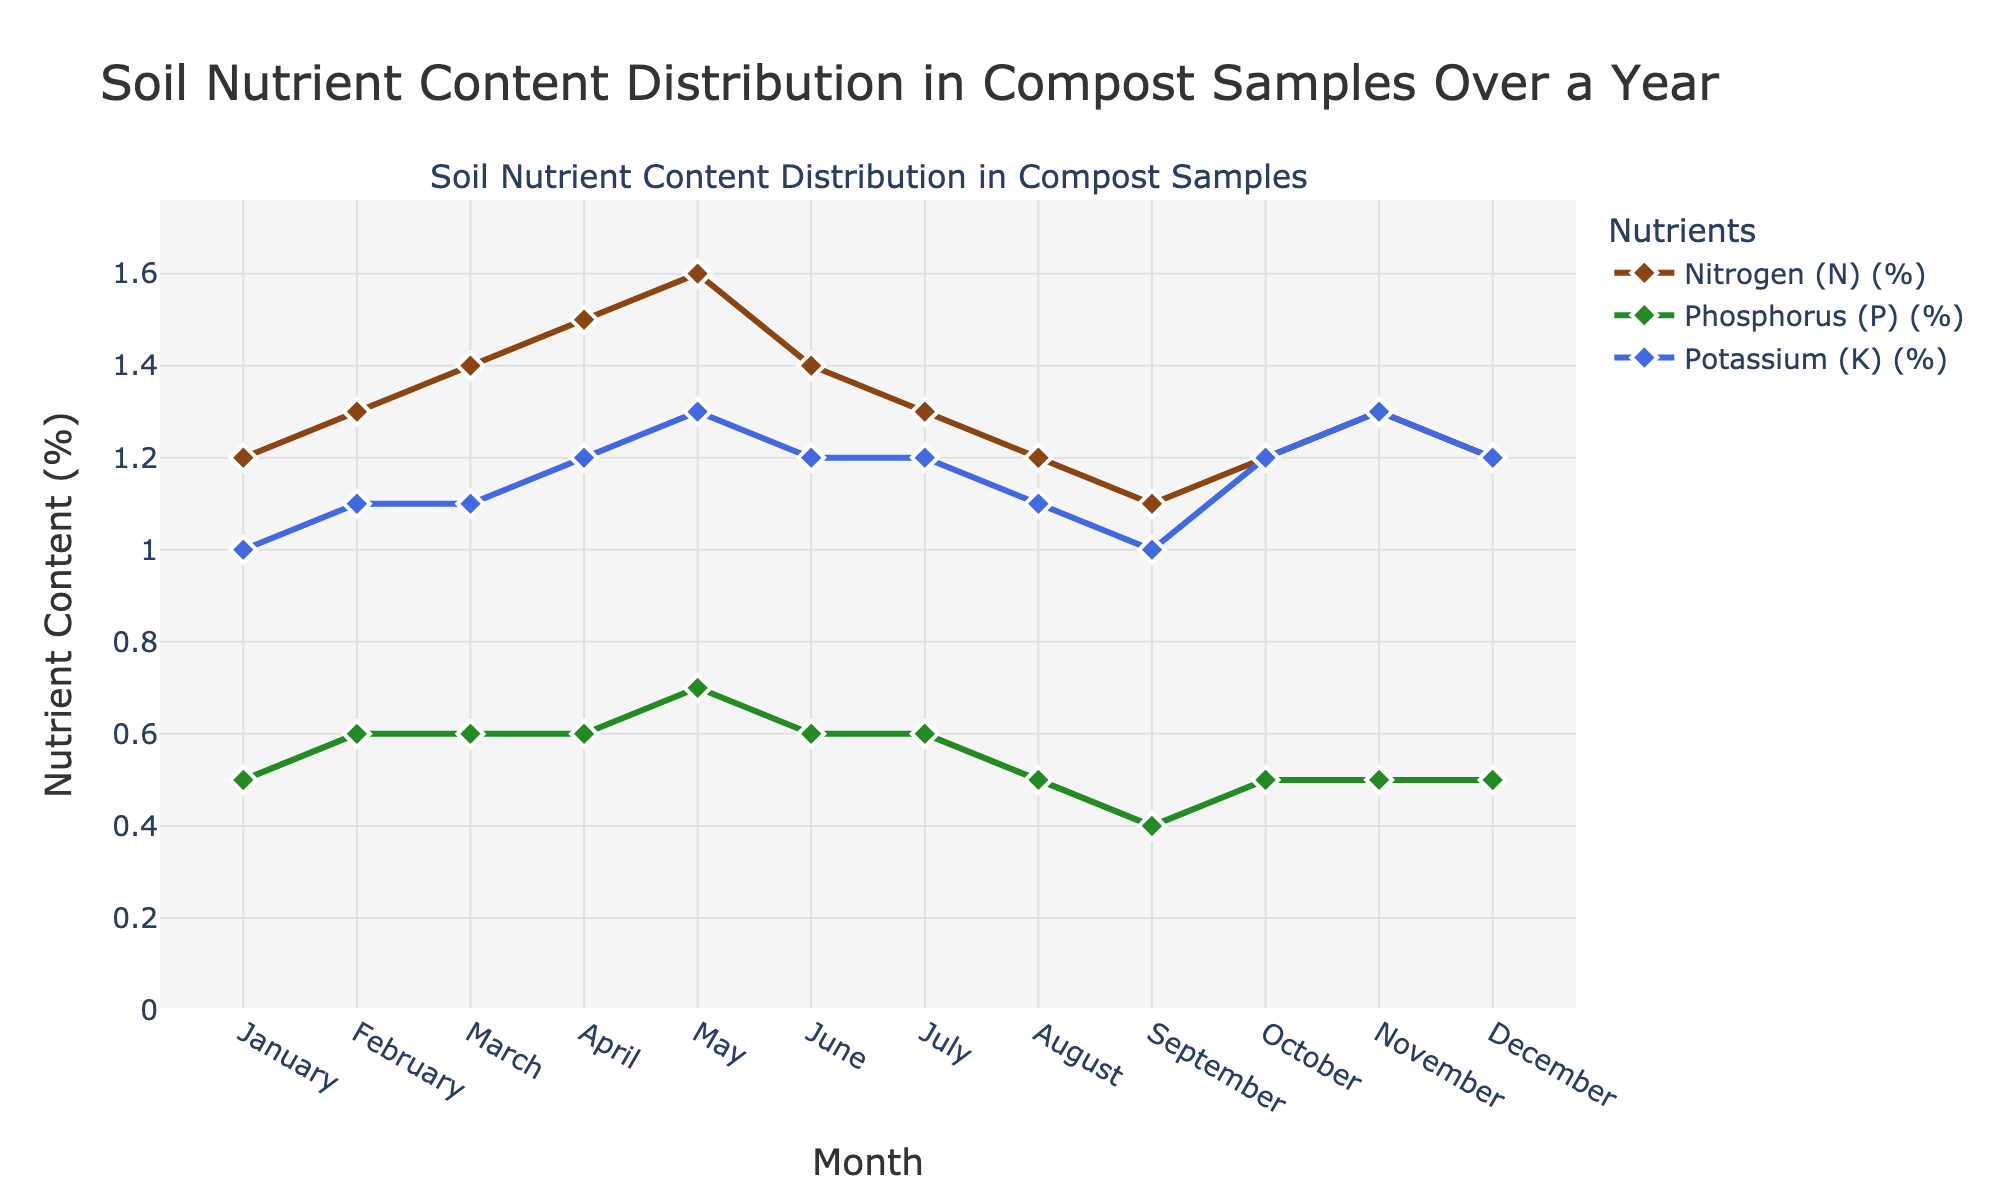What is the title of the figure? The title is usually positioned at the top of the figure. In this case, it is "Soil Nutrient Content Distribution in Compost Samples Over a Year".
Answer: Soil Nutrient Content Distribution in Compost Samples Over a Year Which nutrient consistently has the highest content throughout the year? By observing the lines for each nutrient, the Nitrogen (N) consistently has the highest content compared to Phosphorus (P) and Potassium (K) across all months.
Answer: Nitrogen (N) What are the nutrient content values for Potassium (K) in May? Locate the data point for May and refer to the value connected by the Potassium (K) line, which is marked by a blue color. It's 1.3%.
Answer: 1.3% How does the Nitrogen content change from January to June? Track the Nitrogen (N) line from January to June. The values increase from 1.2% in January to 1.6% in May, then decrease to 1.4% in June.
Answer: Increases initially, then decreases Which month shows the same content value of 1.2% for both Nitrogen and Potassium? Identify the months where the y-values for Nitrogen (N) and Potassium (K) lines both read 1.2%. This occurs in April, October, and December.
Answer: October and December Which nutrient has the lowest content in September? By following the three lines down to the September point, the smallest y-value among them corresponds to Phosphorus (P), 0.4%.
Answer: Phosphorus (P) What is the average Nitrogen content over the year? Sum all monthly Nitrogen values and divide by 12: \( \frac{1.2 + 1.3 + 1.4 + 1.5 + 1.6 + 1.4 + 1.3 + 1.2 + 1.1 + 1.2 + 1.3 + 1.2}{12} \approx 1.3 \).
Answer: 1.3% By how much does the Phosphorus content increase from September to October? The value in September is 0.4%, and the value in October is 0.5%. The difference is \( 0.5\% - 0.4\% = 0.1\% \).
Answer: 0.1% Which month shows a peak in Phosphorus and what is the value? The peak value in the green line (Phosphorus) occurs in May at 0.7%.
Answer: May, 0.7% How many months show an increase in Phosphorus content compared to the previous month? By comparing each month to the previous month, Phosphorus increases in February (+0.1), May (+0.1), June (-0.1), July (0), and November (+0.0). There are three increases (February, May, November).
Answer: 3 